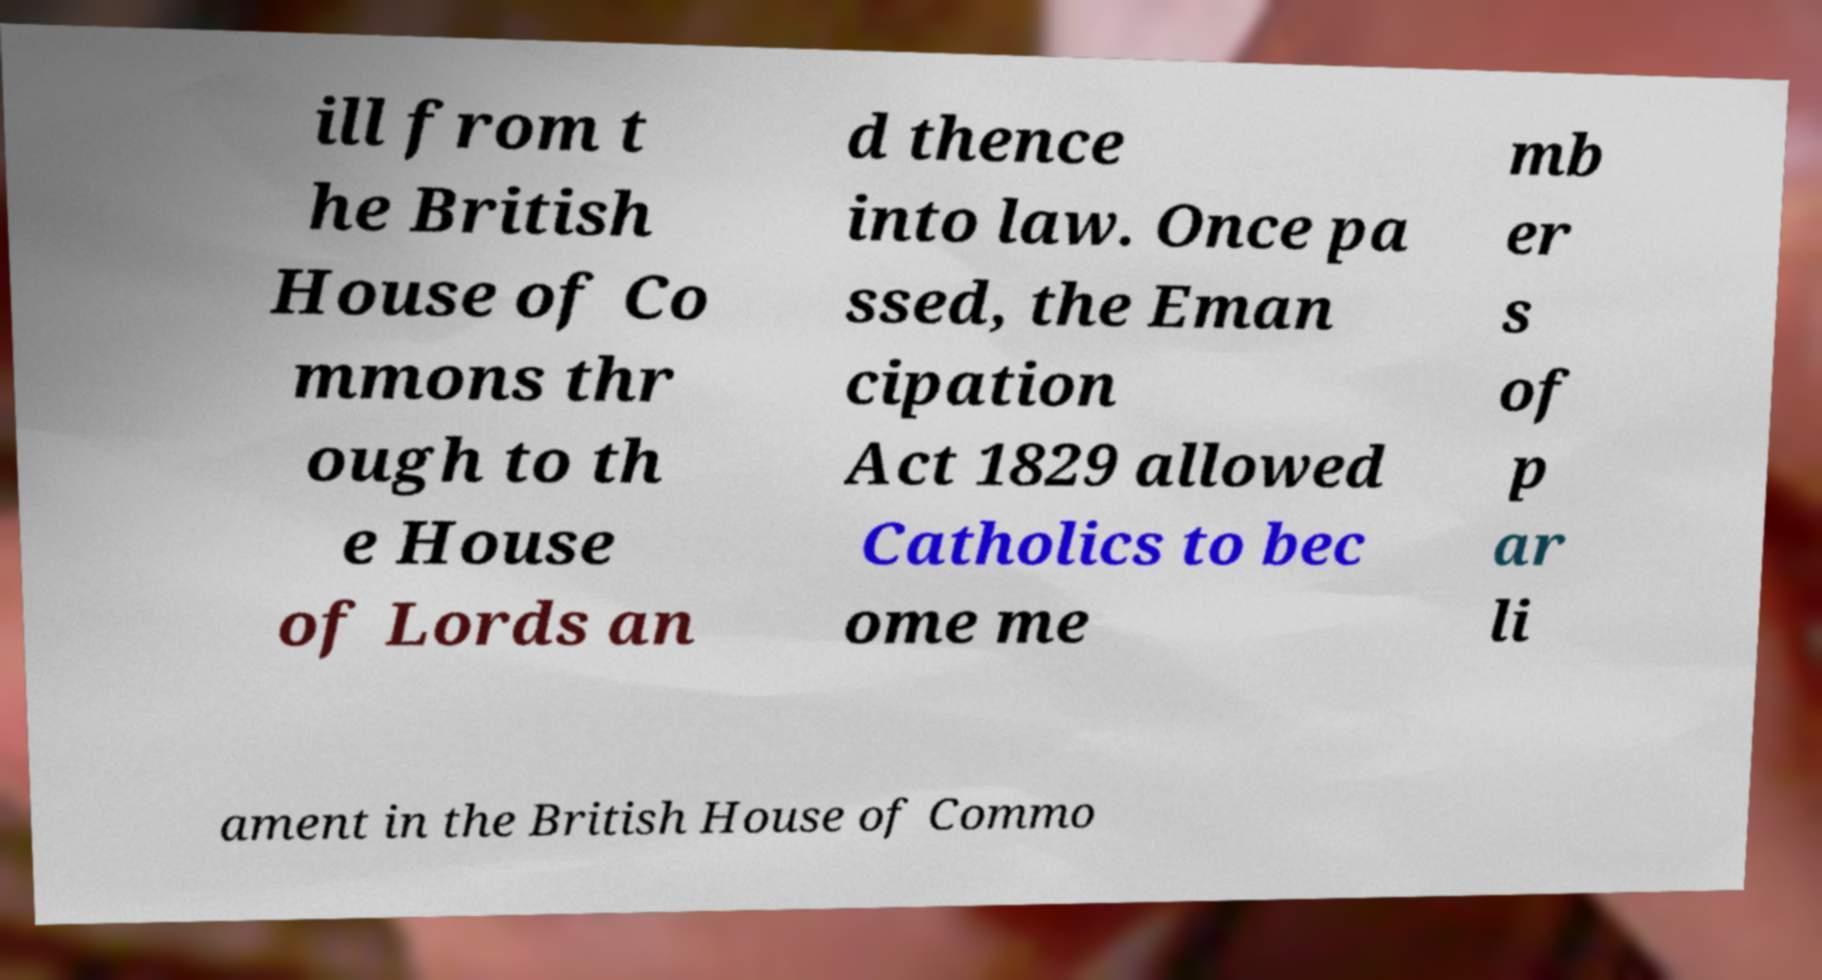Please identify and transcribe the text found in this image. ill from t he British House of Co mmons thr ough to th e House of Lords an d thence into law. Once pa ssed, the Eman cipation Act 1829 allowed Catholics to bec ome me mb er s of p ar li ament in the British House of Commo 